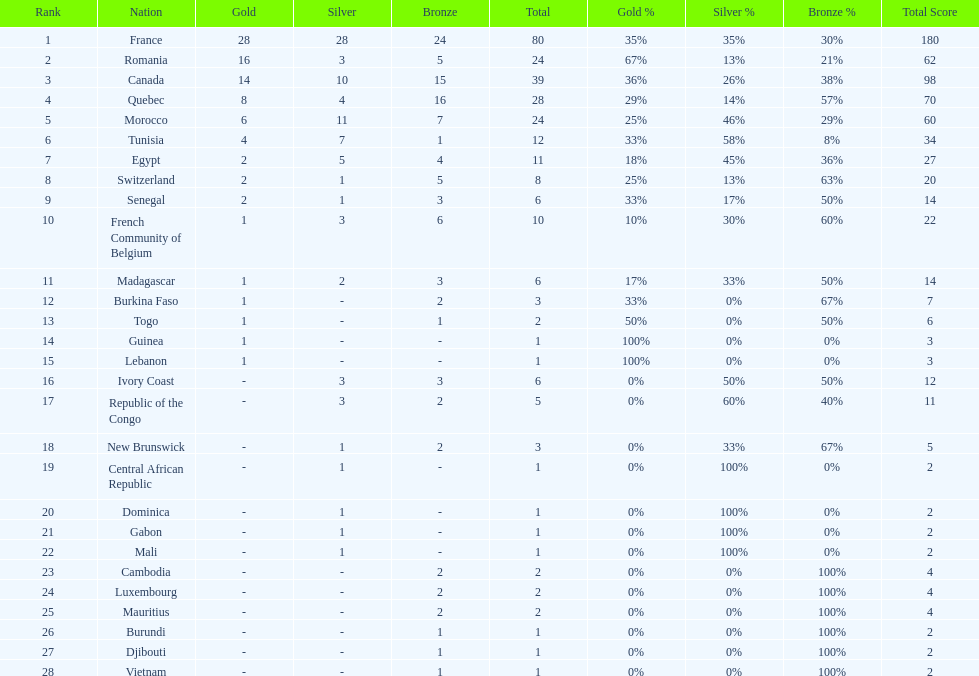Write the full table. {'header': ['Rank', 'Nation', 'Gold', 'Silver', 'Bronze', 'Total', 'Gold %', 'Silver %', 'Bronze %', 'Total Score'], 'rows': [['1', 'France', '28', '28', '24', '80', '35%', '35%', '30%', '180'], ['2', 'Romania', '16', '3', '5', '24', '67%', '13%', '21%', '62'], ['3', 'Canada', '14', '10', '15', '39', '36%', '26%', '38%', '98'], ['4', 'Quebec', '8', '4', '16', '28', '29%', '14%', '57%', '70'], ['5', 'Morocco', '6', '11', '7', '24', '25%', '46%', '29%', '60'], ['6', 'Tunisia', '4', '7', '1', '12', '33%', '58%', '8%', '34'], ['7', 'Egypt', '2', '5', '4', '11', '18%', '45%', '36%', '27'], ['8', 'Switzerland', '2', '1', '5', '8', '25%', '13%', '63%', '20'], ['9', 'Senegal', '2', '1', '3', '6', '33%', '17%', '50%', '14'], ['10', 'French Community of Belgium', '1', '3', '6', '10', '10%', '30%', '60%', '22'], ['11', 'Madagascar', '1', '2', '3', '6', '17%', '33%', '50%', '14'], ['12', 'Burkina Faso', '1', '-', '2', '3', '33%', '0%', '67%', '7'], ['13', 'Togo', '1', '-', '1', '2', '50%', '0%', '50%', '6'], ['14', 'Guinea', '1', '-', '-', '1', '100%', '0%', '0%', '3'], ['15', 'Lebanon', '1', '-', '-', '1', '100%', '0%', '0%', '3'], ['16', 'Ivory Coast', '-', '3', '3', '6', '0%', '50%', '50%', '12'], ['17', 'Republic of the Congo', '-', '3', '2', '5', '0%', '60%', '40%', '11'], ['18', 'New Brunswick', '-', '1', '2', '3', '0%', '33%', '67%', '5'], ['19', 'Central African Republic', '-', '1', '-', '1', '0%', '100%', '0%', '2'], ['20', 'Dominica', '-', '1', '-', '1', '0%', '100%', '0%', '2'], ['21', 'Gabon', '-', '1', '-', '1', '0%', '100%', '0%', '2'], ['22', 'Mali', '-', '1', '-', '1', '0%', '100%', '0%', '2'], ['23', 'Cambodia', '-', '-', '2', '2', '0%', '0%', '100%', '4'], ['24', 'Luxembourg', '-', '-', '2', '2', '0%', '0%', '100%', '4'], ['25', 'Mauritius', '-', '-', '2', '2', '0%', '0%', '100%', '4'], ['26', 'Burundi', '-', '-', '1', '1', '0%', '0%', '100%', '2'], ['27', 'Djibouti', '-', '-', '1', '1', '0%', '0%', '100%', '2'], ['28', 'Vietnam', '-', '-', '1', '1', '0%', '0%', '100%', '2']]} How many nations won at least 10 medals? 8. 